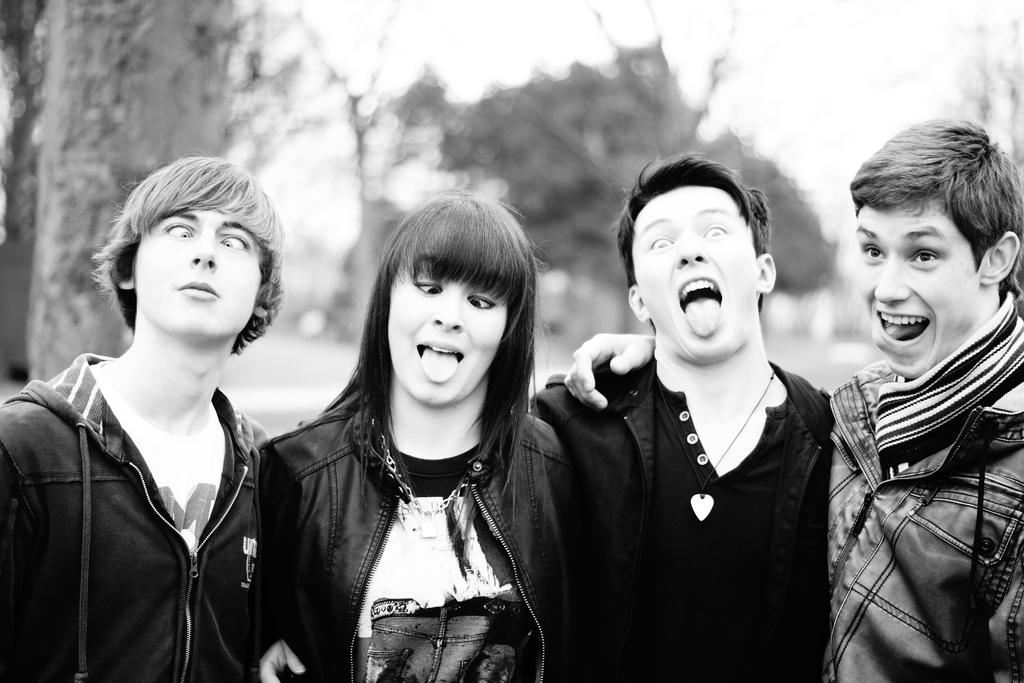How many people are present in the image? There are four people in the image. What are the people wearing? The people are wearing clothes. Can you describe any accessories visible in the image? There is a neck chain visible in the image. What type of clothing item can be seen in the image? There is a jacket in the image. How would you describe the background of the image? The background of the image is blurred. What type of string can be seen connecting the people in the image? There is no string connecting the people in the image; they are not physically linked. Can you recite the verse that is being spoken by the people in the image? There is no verse being spoken by the people in the image; we cannot hear any sounds or conversations. 